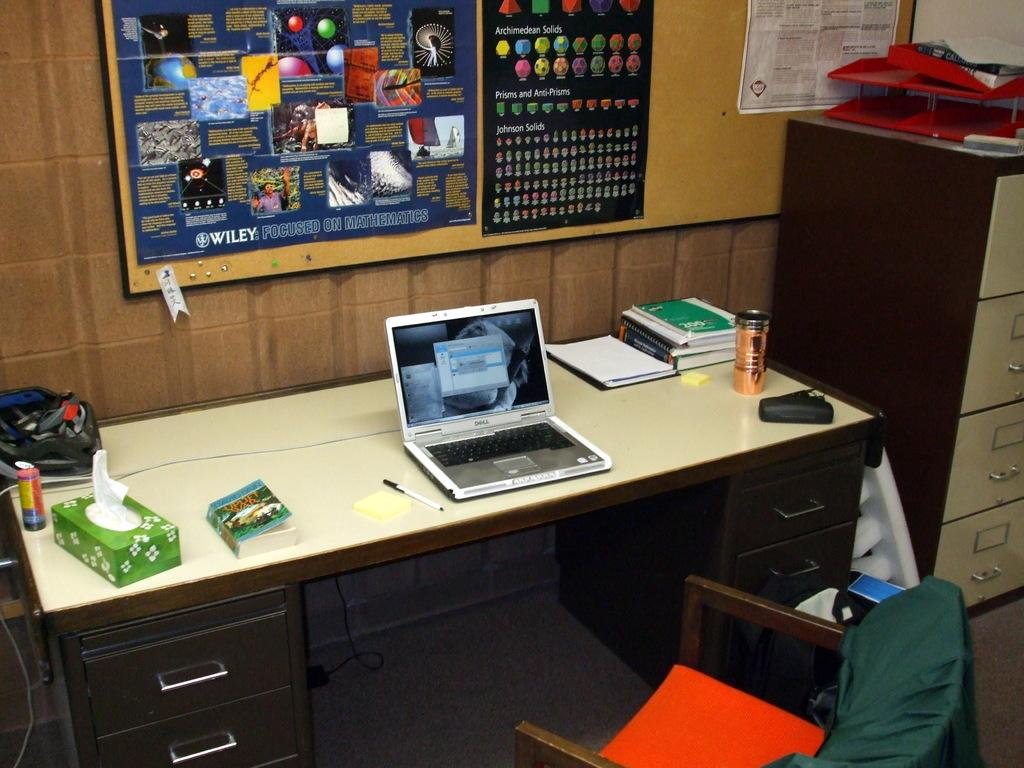<image>
Render a clear and concise summary of the photo. A laptop computer with a cork board with a sign with wiley on the bottom of it. 